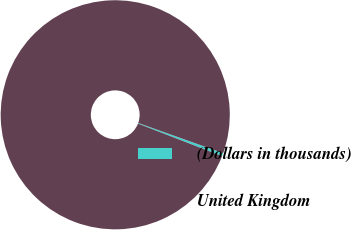Convert chart. <chart><loc_0><loc_0><loc_500><loc_500><pie_chart><fcel>(Dollars in thousands)<fcel>United Kingdom<nl><fcel>0.44%<fcel>99.56%<nl></chart> 